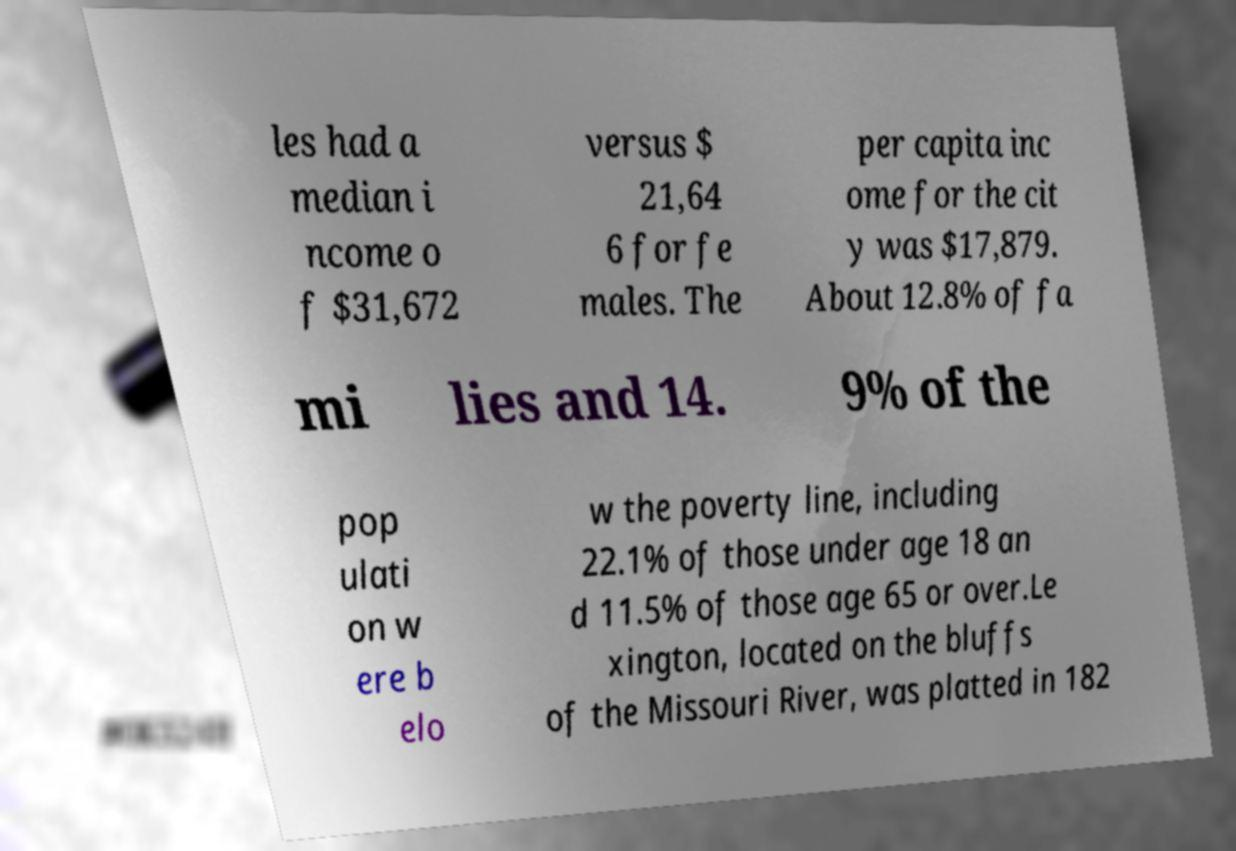For documentation purposes, I need the text within this image transcribed. Could you provide that? les had a median i ncome o f $31,672 versus $ 21,64 6 for fe males. The per capita inc ome for the cit y was $17,879. About 12.8% of fa mi lies and 14. 9% of the pop ulati on w ere b elo w the poverty line, including 22.1% of those under age 18 an d 11.5% of those age 65 or over.Le xington, located on the bluffs of the Missouri River, was platted in 182 